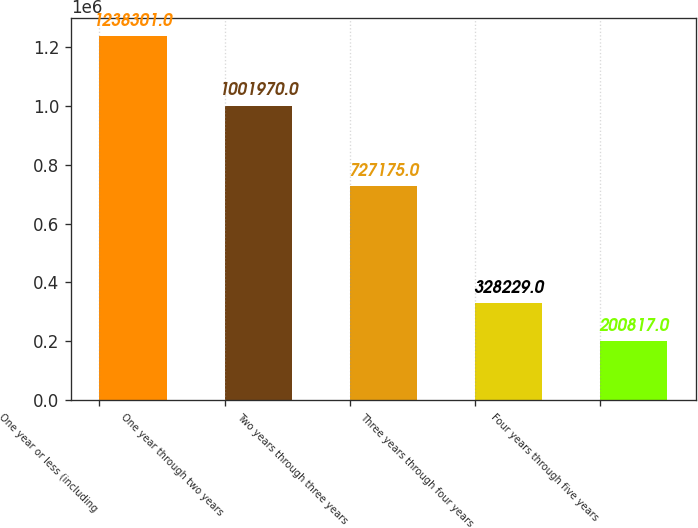Convert chart. <chart><loc_0><loc_0><loc_500><loc_500><bar_chart><fcel>One year or less (including<fcel>One year through two years<fcel>Two years through three years<fcel>Three years through four years<fcel>Four years through five years<nl><fcel>1.2383e+06<fcel>1.00197e+06<fcel>727175<fcel>328229<fcel>200817<nl></chart> 